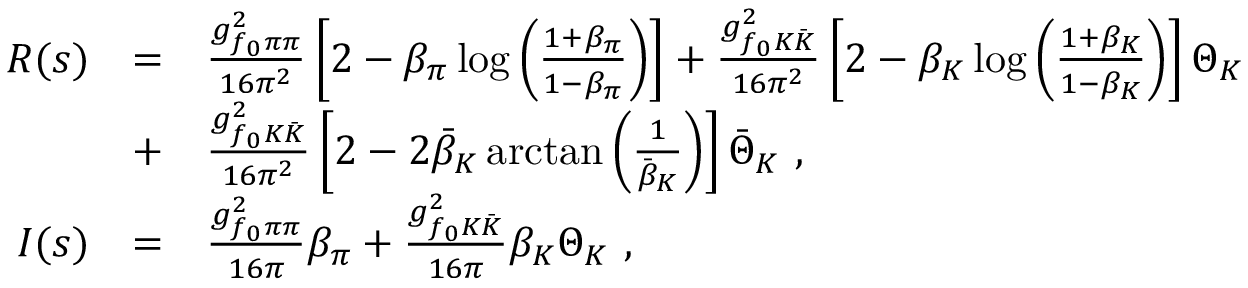<formula> <loc_0><loc_0><loc_500><loc_500>\begin{array} { r c l } { R ( s ) } & { = } & { { \frac { g _ { f _ { 0 } \pi \pi } ^ { 2 } } { 1 6 \pi ^ { 2 } } \left [ 2 - \beta _ { \pi } \log \left ( \frac { 1 + \beta _ { \pi } } { 1 - \beta _ { \pi } } \right ) \right ] + \frac { g _ { f _ { 0 } K \bar { K } } ^ { 2 } } { 1 6 \pi ^ { 2 } } \left [ 2 - \beta _ { K } \log \left ( \frac { 1 + \beta _ { K } } { 1 - \beta _ { K } } \right ) \right ] \Theta _ { K } } } & { + } & { { \frac { g _ { f _ { 0 } K \bar { K } } ^ { 2 } } { 1 6 \pi ^ { 2 } } \left [ 2 - 2 \bar { \beta } _ { K } \arctan \left ( \frac { 1 } { \bar { \beta } _ { K } } \right ) \right ] \bar { \Theta } _ { K } \ , } } \\ { I ( s ) } & { = } & { { \frac { g _ { f _ { 0 } \pi \pi } ^ { 2 } } { 1 6 \pi } \beta _ { \pi } + \frac { g _ { f _ { 0 } K \bar { K } } ^ { 2 } } { 1 6 \pi } \beta _ { K } \Theta _ { K } \ , } } \end{array}</formula> 